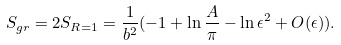<formula> <loc_0><loc_0><loc_500><loc_500>S _ { g r } = 2 S _ { R = 1 } = \frac { 1 } { b ^ { 2 } } ( - 1 + \ln \frac { A } { \pi } - \ln \epsilon ^ { 2 } + O ( \epsilon ) ) .</formula> 